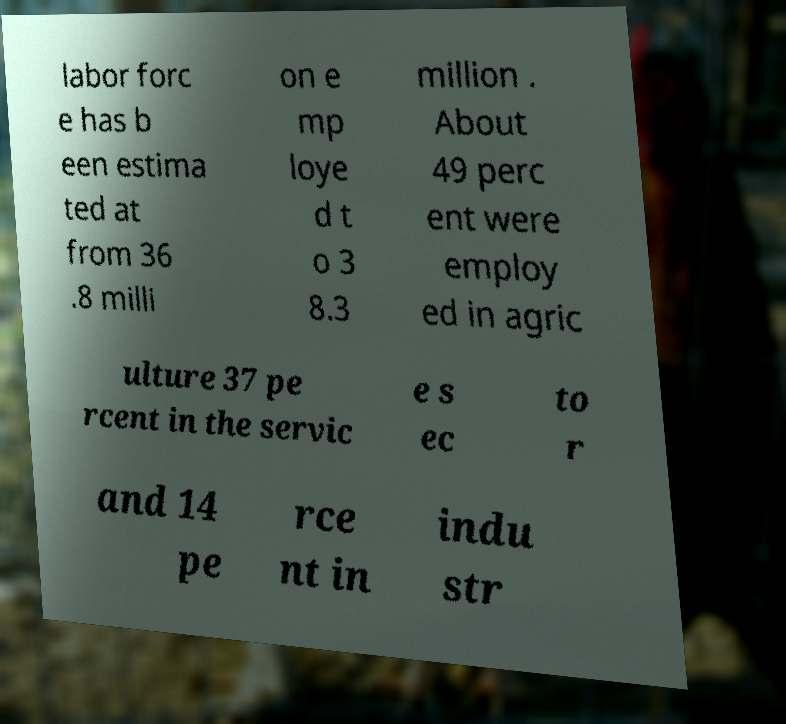Could you assist in decoding the text presented in this image and type it out clearly? labor forc e has b een estima ted at from 36 .8 milli on e mp loye d t o 3 8.3 million . About 49 perc ent were employ ed in agric ulture 37 pe rcent in the servic e s ec to r and 14 pe rce nt in indu str 